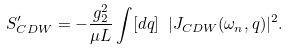<formula> <loc_0><loc_0><loc_500><loc_500>S ^ { \prime } _ { C D W } = - \frac { g ^ { 2 } _ { 2 } } { \mu L } \int [ d q ] \ | J _ { C D W } ( \omega _ { n } , q ) | ^ { 2 } .</formula> 